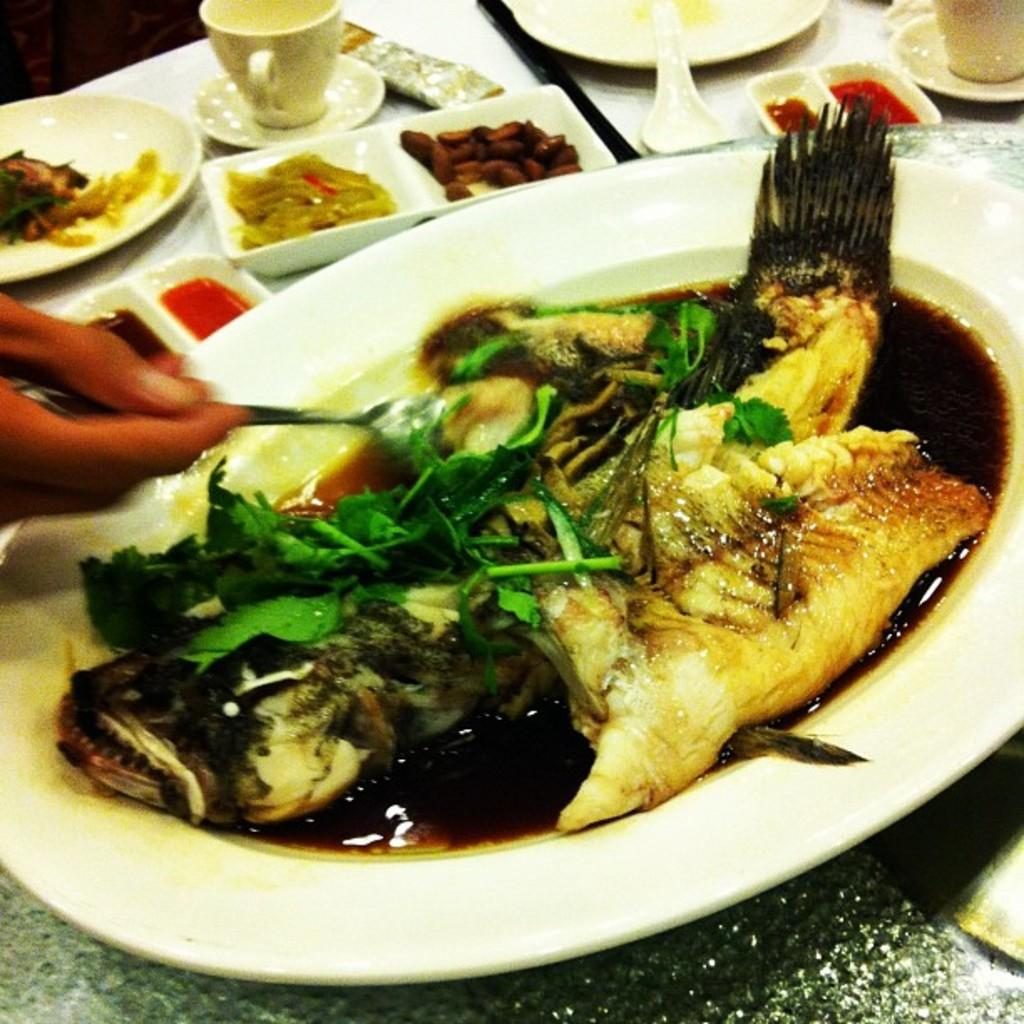What is present on the table in the image? There is food placed on the table. Can you describe the food in the background of the image? There are bowls with food on the table in the background. What type of operation is being performed on the table in the image? There is no operation being performed on the table in the image; it simply shows food placed on it. 